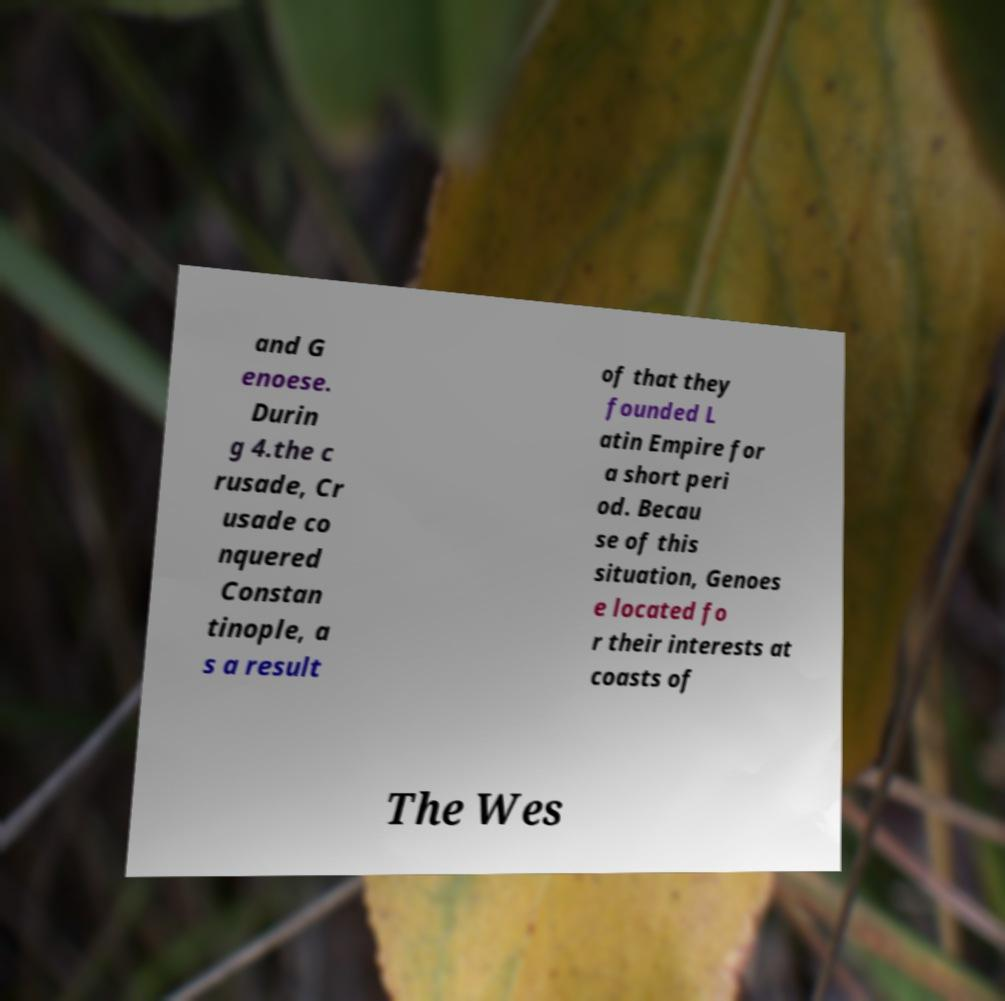Please read and relay the text visible in this image. What does it say? and G enoese. Durin g 4.the c rusade, Cr usade co nquered Constan tinople, a s a result of that they founded L atin Empire for a short peri od. Becau se of this situation, Genoes e located fo r their interests at coasts of The Wes 